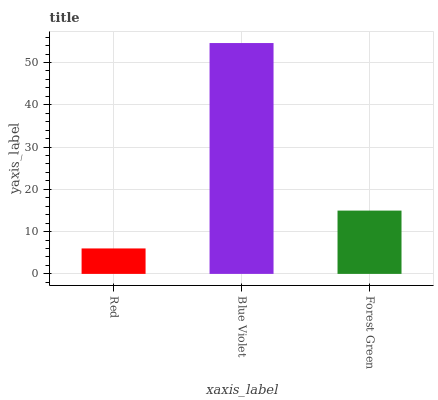Is Red the minimum?
Answer yes or no. Yes. Is Blue Violet the maximum?
Answer yes or no. Yes. Is Forest Green the minimum?
Answer yes or no. No. Is Forest Green the maximum?
Answer yes or no. No. Is Blue Violet greater than Forest Green?
Answer yes or no. Yes. Is Forest Green less than Blue Violet?
Answer yes or no. Yes. Is Forest Green greater than Blue Violet?
Answer yes or no. No. Is Blue Violet less than Forest Green?
Answer yes or no. No. Is Forest Green the high median?
Answer yes or no. Yes. Is Forest Green the low median?
Answer yes or no. Yes. Is Blue Violet the high median?
Answer yes or no. No. Is Blue Violet the low median?
Answer yes or no. No. 